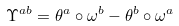Convert formula to latex. <formula><loc_0><loc_0><loc_500><loc_500>\Upsilon ^ { a b } = \theta ^ { a } \circ \omega ^ { b } - \theta ^ { b } \circ \omega ^ { a }</formula> 